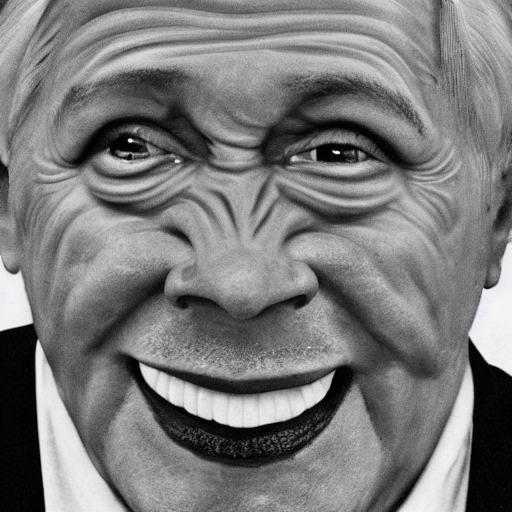What emotions does the person in the image seem to be expressing? The individual appears to be expressing joviality and amusement, as indicated by the wide smile and crinkles around the eyes that suggest a genuine sense of happiness. 